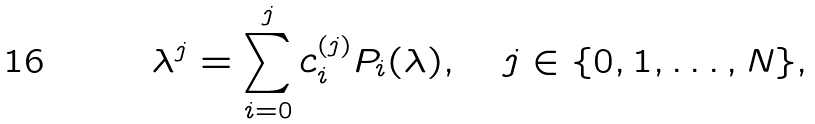Convert formula to latex. <formula><loc_0><loc_0><loc_500><loc_500>\lambda ^ { j } = \sum _ { i = 0 } ^ { j } c _ { i } ^ { ( j ) } P _ { i } ( \lambda ) , \quad j \in \{ 0 , 1 , \dots , N \} ,</formula> 